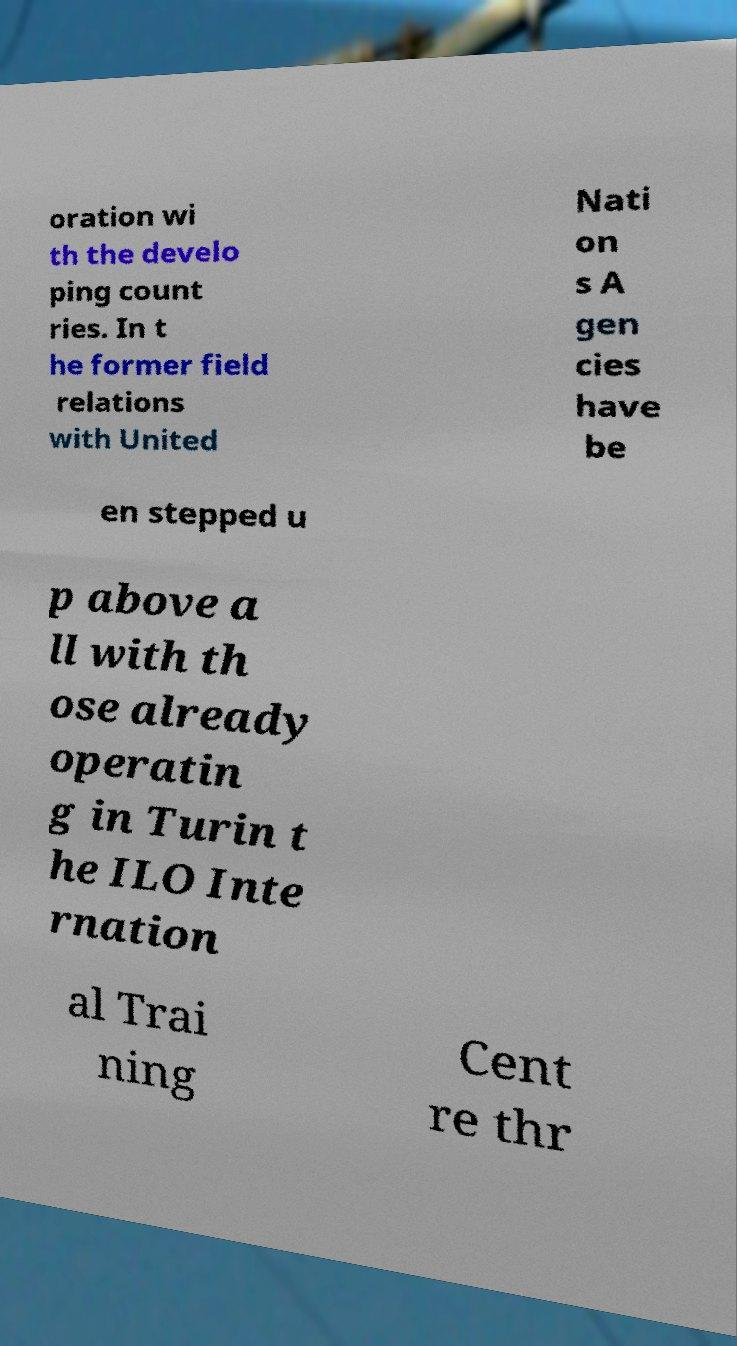Can you read and provide the text displayed in the image?This photo seems to have some interesting text. Can you extract and type it out for me? oration wi th the develo ping count ries. In t he former field relations with United Nati on s A gen cies have be en stepped u p above a ll with th ose already operatin g in Turin t he ILO Inte rnation al Trai ning Cent re thr 